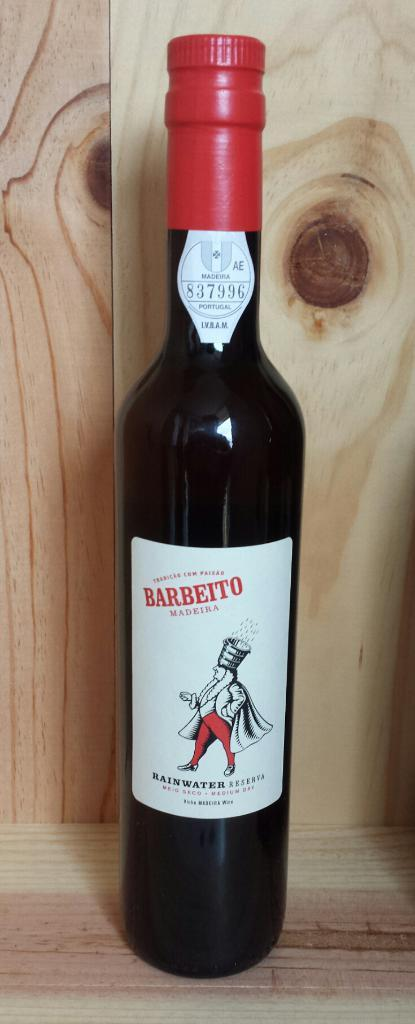<image>
Summarize the visual content of the image. A bottle of Barbeito Madeira on a wooden shelf. 